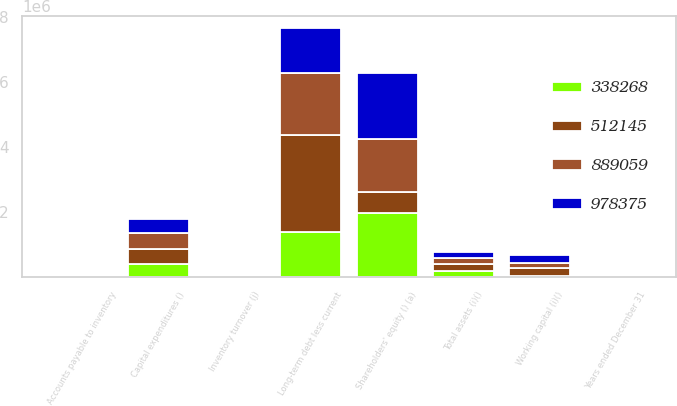<chart> <loc_0><loc_0><loc_500><loc_500><stacked_bar_chart><ecel><fcel>Years ended December 31<fcel>Working capital (i)()<fcel>Total assets (i)()<fcel>Inventory turnover (j)<fcel>Accounts payable to inventory<fcel>Long-term debt less current<fcel>Shareholders' equity () (a)<fcel>Capital expenditures ()<nl><fcel>512145<fcel>2017<fcel>249694<fcel>196184<fcel>1.4<fcel>106<fcel>2.97839e+06<fcel>653046<fcel>465940<nl><fcel>889059<fcel>2016<fcel>142674<fcel>196184<fcel>1.5<fcel>105.7<fcel>1.88702e+06<fcel>1.62714e+06<fcel>476344<nl><fcel>338268<fcel>2015<fcel>36372<fcel>196184<fcel>1.5<fcel>99.1<fcel>1.39002e+06<fcel>1.96131e+06<fcel>414020<nl><fcel>978375<fcel>2014<fcel>252082<fcel>196184<fcel>1.4<fcel>94.6<fcel>1.3884e+06<fcel>2.01842e+06<fcel>429987<nl></chart> 